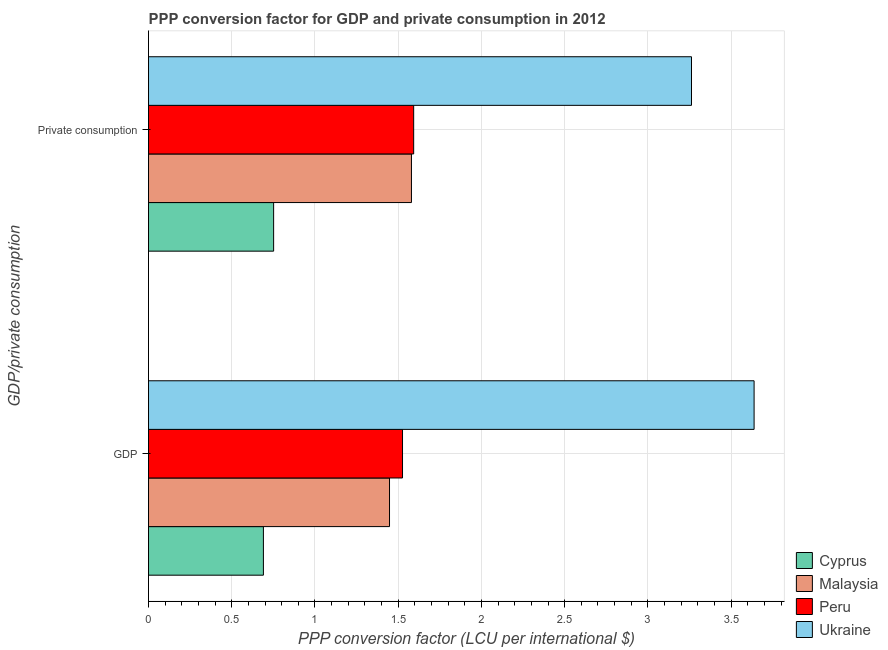How many groups of bars are there?
Make the answer very short. 2. Are the number of bars per tick equal to the number of legend labels?
Give a very brief answer. Yes. Are the number of bars on each tick of the Y-axis equal?
Ensure brevity in your answer.  Yes. How many bars are there on the 2nd tick from the top?
Offer a very short reply. 4. How many bars are there on the 1st tick from the bottom?
Provide a succinct answer. 4. What is the label of the 2nd group of bars from the top?
Give a very brief answer. GDP. What is the ppp conversion factor for gdp in Malaysia?
Give a very brief answer. 1.45. Across all countries, what is the maximum ppp conversion factor for private consumption?
Provide a succinct answer. 3.26. Across all countries, what is the minimum ppp conversion factor for gdp?
Offer a terse response. 0.69. In which country was the ppp conversion factor for private consumption maximum?
Offer a very short reply. Ukraine. In which country was the ppp conversion factor for gdp minimum?
Your answer should be compact. Cyprus. What is the total ppp conversion factor for gdp in the graph?
Provide a succinct answer. 7.3. What is the difference between the ppp conversion factor for private consumption in Peru and that in Cyprus?
Give a very brief answer. 0.84. What is the difference between the ppp conversion factor for gdp in Cyprus and the ppp conversion factor for private consumption in Ukraine?
Make the answer very short. -2.57. What is the average ppp conversion factor for private consumption per country?
Give a very brief answer. 1.8. What is the difference between the ppp conversion factor for gdp and ppp conversion factor for private consumption in Malaysia?
Offer a very short reply. -0.13. What is the ratio of the ppp conversion factor for gdp in Malaysia to that in Cyprus?
Provide a short and direct response. 2.1. What does the 3rd bar from the top in GDP represents?
Offer a terse response. Malaysia. What does the 2nd bar from the bottom in GDP represents?
Your answer should be compact. Malaysia. How many bars are there?
Ensure brevity in your answer.  8. Are all the bars in the graph horizontal?
Your answer should be compact. Yes. How many countries are there in the graph?
Ensure brevity in your answer.  4. What is the difference between two consecutive major ticks on the X-axis?
Your answer should be compact. 0.5. Are the values on the major ticks of X-axis written in scientific E-notation?
Offer a terse response. No. How are the legend labels stacked?
Make the answer very short. Vertical. What is the title of the graph?
Give a very brief answer. PPP conversion factor for GDP and private consumption in 2012. What is the label or title of the X-axis?
Offer a terse response. PPP conversion factor (LCU per international $). What is the label or title of the Y-axis?
Your answer should be very brief. GDP/private consumption. What is the PPP conversion factor (LCU per international $) in Cyprus in GDP?
Your answer should be compact. 0.69. What is the PPP conversion factor (LCU per international $) in Malaysia in GDP?
Provide a short and direct response. 1.45. What is the PPP conversion factor (LCU per international $) in Peru in GDP?
Give a very brief answer. 1.53. What is the PPP conversion factor (LCU per international $) in Ukraine in GDP?
Offer a terse response. 3.64. What is the PPP conversion factor (LCU per international $) in Cyprus in  Private consumption?
Your response must be concise. 0.75. What is the PPP conversion factor (LCU per international $) of Malaysia in  Private consumption?
Give a very brief answer. 1.58. What is the PPP conversion factor (LCU per international $) in Peru in  Private consumption?
Provide a short and direct response. 1.59. What is the PPP conversion factor (LCU per international $) in Ukraine in  Private consumption?
Provide a succinct answer. 3.26. Across all GDP/private consumption, what is the maximum PPP conversion factor (LCU per international $) of Cyprus?
Ensure brevity in your answer.  0.75. Across all GDP/private consumption, what is the maximum PPP conversion factor (LCU per international $) in Malaysia?
Your answer should be very brief. 1.58. Across all GDP/private consumption, what is the maximum PPP conversion factor (LCU per international $) in Peru?
Offer a terse response. 1.59. Across all GDP/private consumption, what is the maximum PPP conversion factor (LCU per international $) of Ukraine?
Your answer should be compact. 3.64. Across all GDP/private consumption, what is the minimum PPP conversion factor (LCU per international $) of Cyprus?
Provide a succinct answer. 0.69. Across all GDP/private consumption, what is the minimum PPP conversion factor (LCU per international $) in Malaysia?
Provide a short and direct response. 1.45. Across all GDP/private consumption, what is the minimum PPP conversion factor (LCU per international $) in Peru?
Your answer should be compact. 1.53. Across all GDP/private consumption, what is the minimum PPP conversion factor (LCU per international $) in Ukraine?
Offer a terse response. 3.26. What is the total PPP conversion factor (LCU per international $) of Cyprus in the graph?
Your response must be concise. 1.44. What is the total PPP conversion factor (LCU per international $) in Malaysia in the graph?
Your answer should be very brief. 3.03. What is the total PPP conversion factor (LCU per international $) of Peru in the graph?
Provide a short and direct response. 3.12. What is the total PPP conversion factor (LCU per international $) of Ukraine in the graph?
Provide a succinct answer. 6.9. What is the difference between the PPP conversion factor (LCU per international $) of Cyprus in GDP and that in  Private consumption?
Ensure brevity in your answer.  -0.06. What is the difference between the PPP conversion factor (LCU per international $) of Malaysia in GDP and that in  Private consumption?
Make the answer very short. -0.13. What is the difference between the PPP conversion factor (LCU per international $) of Peru in GDP and that in  Private consumption?
Your answer should be compact. -0.07. What is the difference between the PPP conversion factor (LCU per international $) of Ukraine in GDP and that in  Private consumption?
Your answer should be very brief. 0.38. What is the difference between the PPP conversion factor (LCU per international $) of Cyprus in GDP and the PPP conversion factor (LCU per international $) of Malaysia in  Private consumption?
Give a very brief answer. -0.89. What is the difference between the PPP conversion factor (LCU per international $) of Cyprus in GDP and the PPP conversion factor (LCU per international $) of Peru in  Private consumption?
Provide a succinct answer. -0.9. What is the difference between the PPP conversion factor (LCU per international $) in Cyprus in GDP and the PPP conversion factor (LCU per international $) in Ukraine in  Private consumption?
Provide a short and direct response. -2.57. What is the difference between the PPP conversion factor (LCU per international $) in Malaysia in GDP and the PPP conversion factor (LCU per international $) in Peru in  Private consumption?
Offer a very short reply. -0.15. What is the difference between the PPP conversion factor (LCU per international $) in Malaysia in GDP and the PPP conversion factor (LCU per international $) in Ukraine in  Private consumption?
Your answer should be compact. -1.81. What is the difference between the PPP conversion factor (LCU per international $) of Peru in GDP and the PPP conversion factor (LCU per international $) of Ukraine in  Private consumption?
Your response must be concise. -1.74. What is the average PPP conversion factor (LCU per international $) in Cyprus per GDP/private consumption?
Provide a short and direct response. 0.72. What is the average PPP conversion factor (LCU per international $) in Malaysia per GDP/private consumption?
Provide a short and direct response. 1.51. What is the average PPP conversion factor (LCU per international $) of Peru per GDP/private consumption?
Ensure brevity in your answer.  1.56. What is the average PPP conversion factor (LCU per international $) of Ukraine per GDP/private consumption?
Provide a short and direct response. 3.45. What is the difference between the PPP conversion factor (LCU per international $) in Cyprus and PPP conversion factor (LCU per international $) in Malaysia in GDP?
Offer a terse response. -0.76. What is the difference between the PPP conversion factor (LCU per international $) in Cyprus and PPP conversion factor (LCU per international $) in Peru in GDP?
Keep it short and to the point. -0.84. What is the difference between the PPP conversion factor (LCU per international $) of Cyprus and PPP conversion factor (LCU per international $) of Ukraine in GDP?
Your response must be concise. -2.95. What is the difference between the PPP conversion factor (LCU per international $) in Malaysia and PPP conversion factor (LCU per international $) in Peru in GDP?
Offer a very short reply. -0.08. What is the difference between the PPP conversion factor (LCU per international $) of Malaysia and PPP conversion factor (LCU per international $) of Ukraine in GDP?
Your answer should be very brief. -2.19. What is the difference between the PPP conversion factor (LCU per international $) of Peru and PPP conversion factor (LCU per international $) of Ukraine in GDP?
Your response must be concise. -2.11. What is the difference between the PPP conversion factor (LCU per international $) of Cyprus and PPP conversion factor (LCU per international $) of Malaysia in  Private consumption?
Your answer should be compact. -0.83. What is the difference between the PPP conversion factor (LCU per international $) in Cyprus and PPP conversion factor (LCU per international $) in Peru in  Private consumption?
Your answer should be compact. -0.84. What is the difference between the PPP conversion factor (LCU per international $) of Cyprus and PPP conversion factor (LCU per international $) of Ukraine in  Private consumption?
Keep it short and to the point. -2.51. What is the difference between the PPP conversion factor (LCU per international $) in Malaysia and PPP conversion factor (LCU per international $) in Peru in  Private consumption?
Give a very brief answer. -0.01. What is the difference between the PPP conversion factor (LCU per international $) in Malaysia and PPP conversion factor (LCU per international $) in Ukraine in  Private consumption?
Give a very brief answer. -1.68. What is the difference between the PPP conversion factor (LCU per international $) of Peru and PPP conversion factor (LCU per international $) of Ukraine in  Private consumption?
Offer a terse response. -1.67. What is the ratio of the PPP conversion factor (LCU per international $) in Cyprus in GDP to that in  Private consumption?
Your answer should be compact. 0.92. What is the ratio of the PPP conversion factor (LCU per international $) of Malaysia in GDP to that in  Private consumption?
Provide a short and direct response. 0.92. What is the ratio of the PPP conversion factor (LCU per international $) of Peru in GDP to that in  Private consumption?
Make the answer very short. 0.96. What is the ratio of the PPP conversion factor (LCU per international $) in Ukraine in GDP to that in  Private consumption?
Offer a very short reply. 1.12. What is the difference between the highest and the second highest PPP conversion factor (LCU per international $) in Cyprus?
Your answer should be compact. 0.06. What is the difference between the highest and the second highest PPP conversion factor (LCU per international $) of Malaysia?
Give a very brief answer. 0.13. What is the difference between the highest and the second highest PPP conversion factor (LCU per international $) of Peru?
Offer a very short reply. 0.07. What is the difference between the highest and the second highest PPP conversion factor (LCU per international $) of Ukraine?
Offer a terse response. 0.38. What is the difference between the highest and the lowest PPP conversion factor (LCU per international $) of Cyprus?
Your answer should be compact. 0.06. What is the difference between the highest and the lowest PPP conversion factor (LCU per international $) in Malaysia?
Give a very brief answer. 0.13. What is the difference between the highest and the lowest PPP conversion factor (LCU per international $) in Peru?
Provide a succinct answer. 0.07. What is the difference between the highest and the lowest PPP conversion factor (LCU per international $) in Ukraine?
Give a very brief answer. 0.38. 